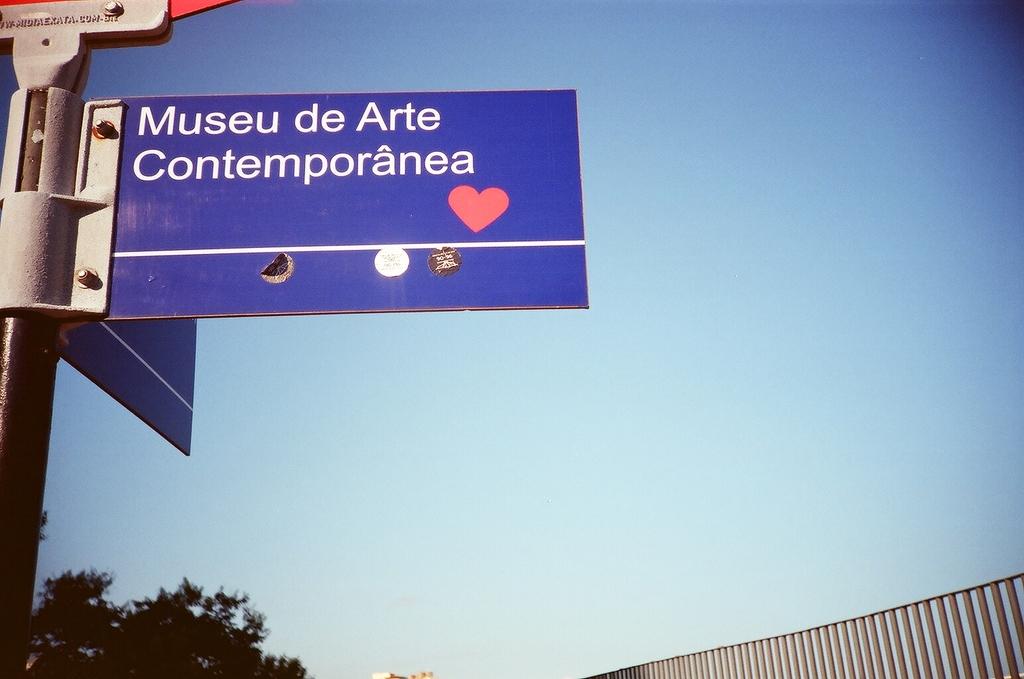What is the word that comes after arte?
Offer a terse response. Contemporanea. 